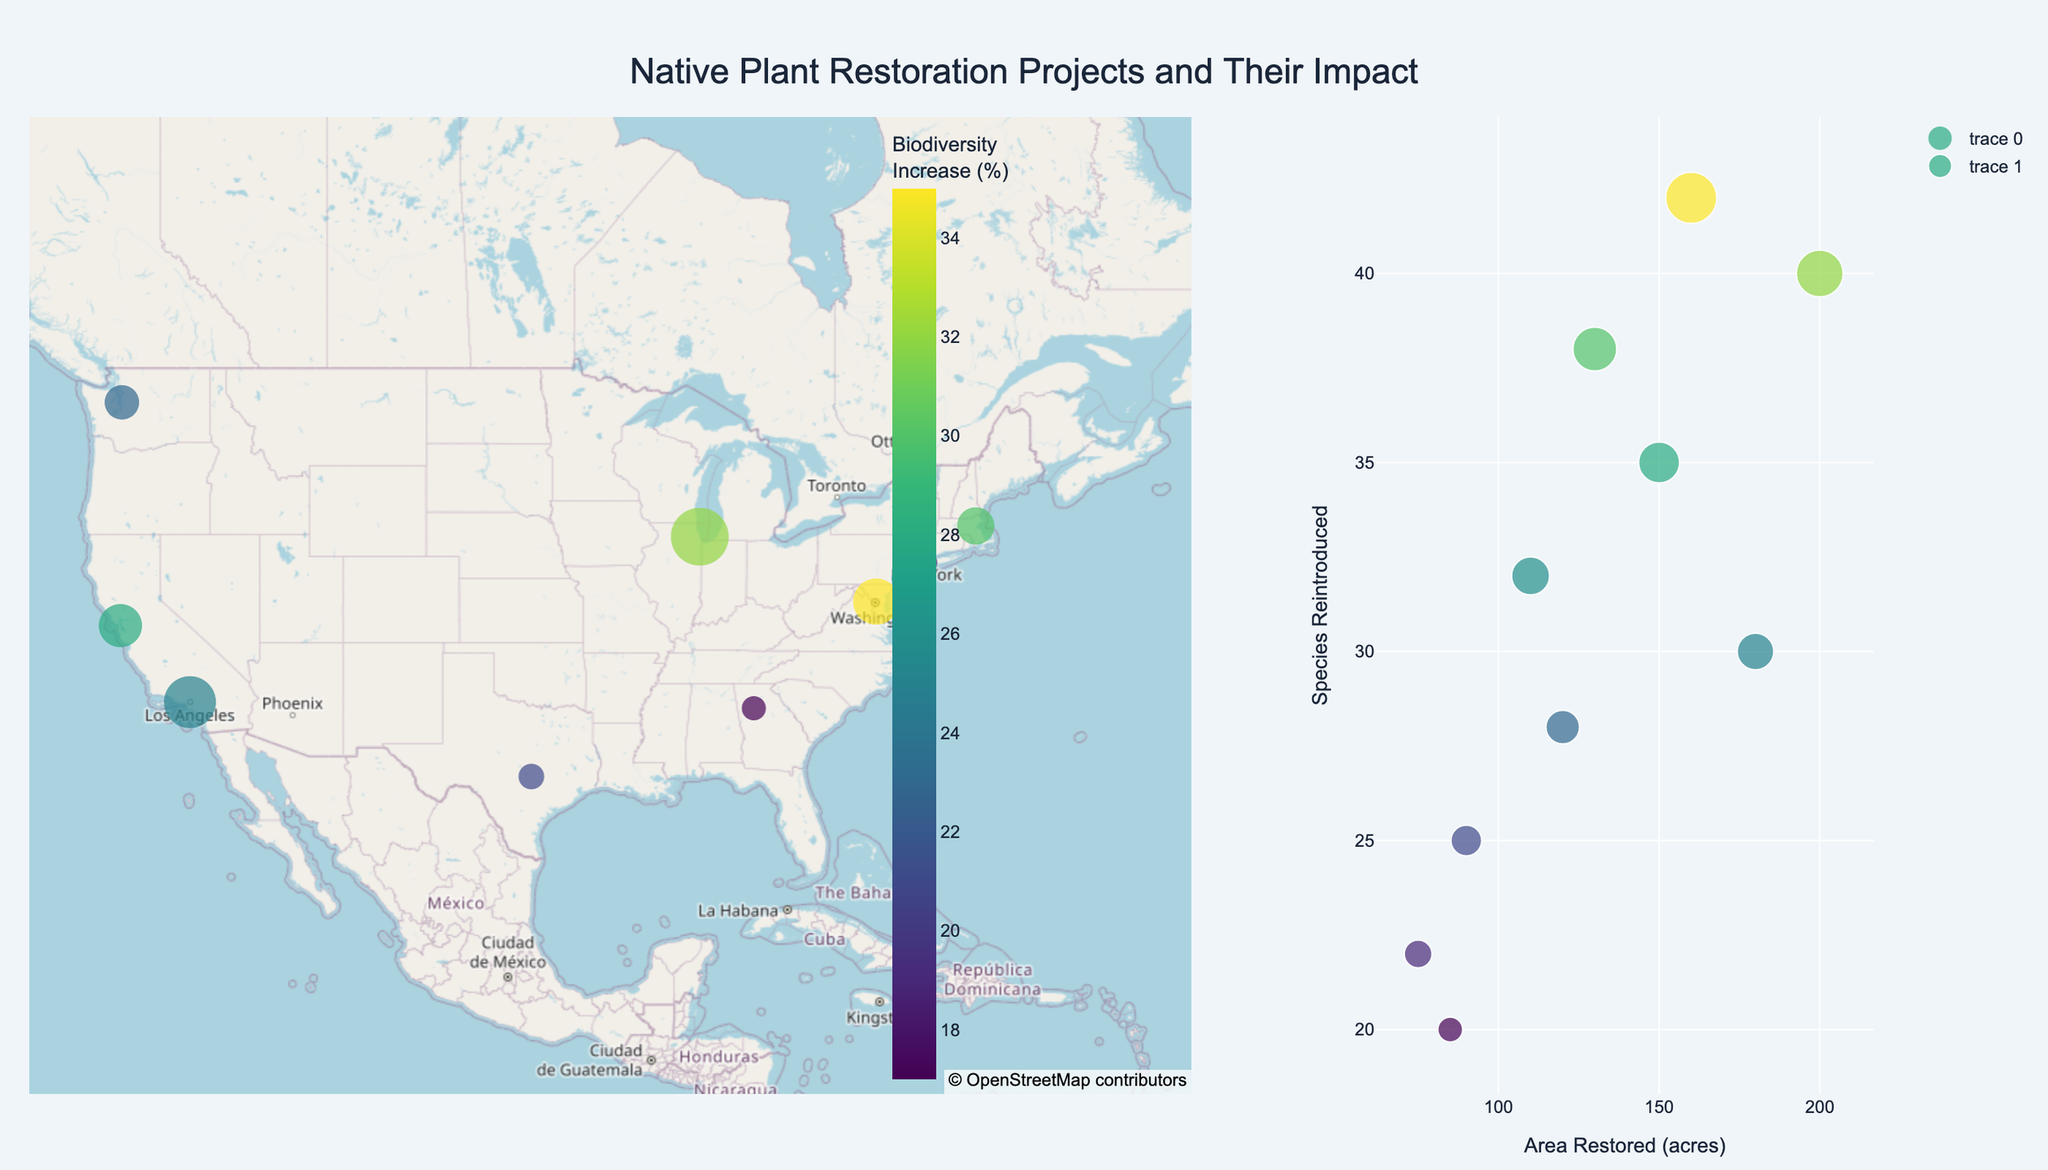What is the title of the figure? The title is displayed at the top of the figure and summarizes the information presented. In this figure, the title text appears between the mapbox and scatter plot sections.
Answer: Native Plant Restoration Projects and Their Impact How many data points are represented on the map? By counting the markers on the map, each representing a restoration project, we can determine the number of data points. Count the markers visible on the map to get the total.
Answer: 10 Which location has the highest biodiversity increase percentage? To identify this, check the color bar scale or hover over the markers on the map to see the biodiversity increase values. The highest value is 35% for the Anacostia Watershed Revitalization project.
Answer: Washington DC What is the average area restored across all projects? Sum the values of 'Area Restored (acres)' column and divide by the number of projects. (150 + 75 + 200 + 180 + 120 + 90 + 110 + 130 + 85 + 160) / 10 = 130
Answer: 130 acres Which project reintroduced the most species? In the scatter plot or by examining the map hover texts, identify the project with the highest 'Species Reintroduced' value, which is the Anacostia Watershed Revitalization with 42 species.
Answer: Anacostia Watershed Revitalization What is the total area restored in California? List the projects located in California (Golden Gate Park Restoration and Griffith Park Native Chaparral), sum their 'Area Restored (acres)' amounts. (150 + 180)
Answer: 330 acres Compare the biodiversity increase percentages of the Golden Gate Park Restoration and Charles River Wetlands Project. Which is higher? Look up the biodiversity increase percentages for these projects on the map or scatter plot. Golden Gate Park Restoration has 28% and Charles River Wetlands Project has 30%. Identify the higher value.
Answer: Charles River Wetlands Project Is there a visible correlation between the area restored and the number of species reintroduced in the scatter plot? Observe the scatter plot where the x-axis represents 'Area Restored (acres)' and the y-axis represents 'Species Reintroduced'. A positive trend suggests a correlation. There is a positive correlation.
Answer: Yes Which project is located closest to the geographic center of the USA? Based on the latitude and longitude, the project near the geographic center (using coordinates roughly (39°, -98°)) is Barton Creek Habitat Recovery in Austin, TX.
Answer: Barton Creek Habitat Recovery What is the color scale used in the map? The color scale, indicated by the legend next to the map, ranges in colors representing biodiversity increase percentages. The scale is 'Viridis'.
Answer: Viridis 